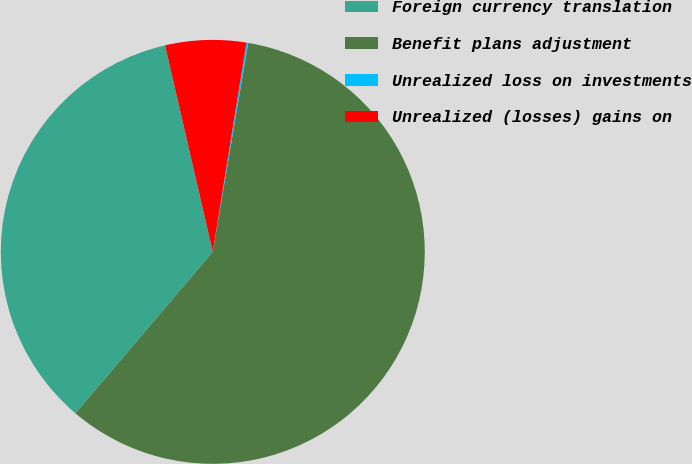Convert chart to OTSL. <chart><loc_0><loc_0><loc_500><loc_500><pie_chart><fcel>Foreign currency translation<fcel>Benefit plans adjustment<fcel>Unrealized loss on investments<fcel>Unrealized (losses) gains on<nl><fcel>35.17%<fcel>58.54%<fcel>0.14%<fcel>6.15%<nl></chart> 